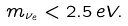<formula> <loc_0><loc_0><loc_500><loc_500>m _ { \nu _ { e } } < 2 . 5 \, e V .</formula> 